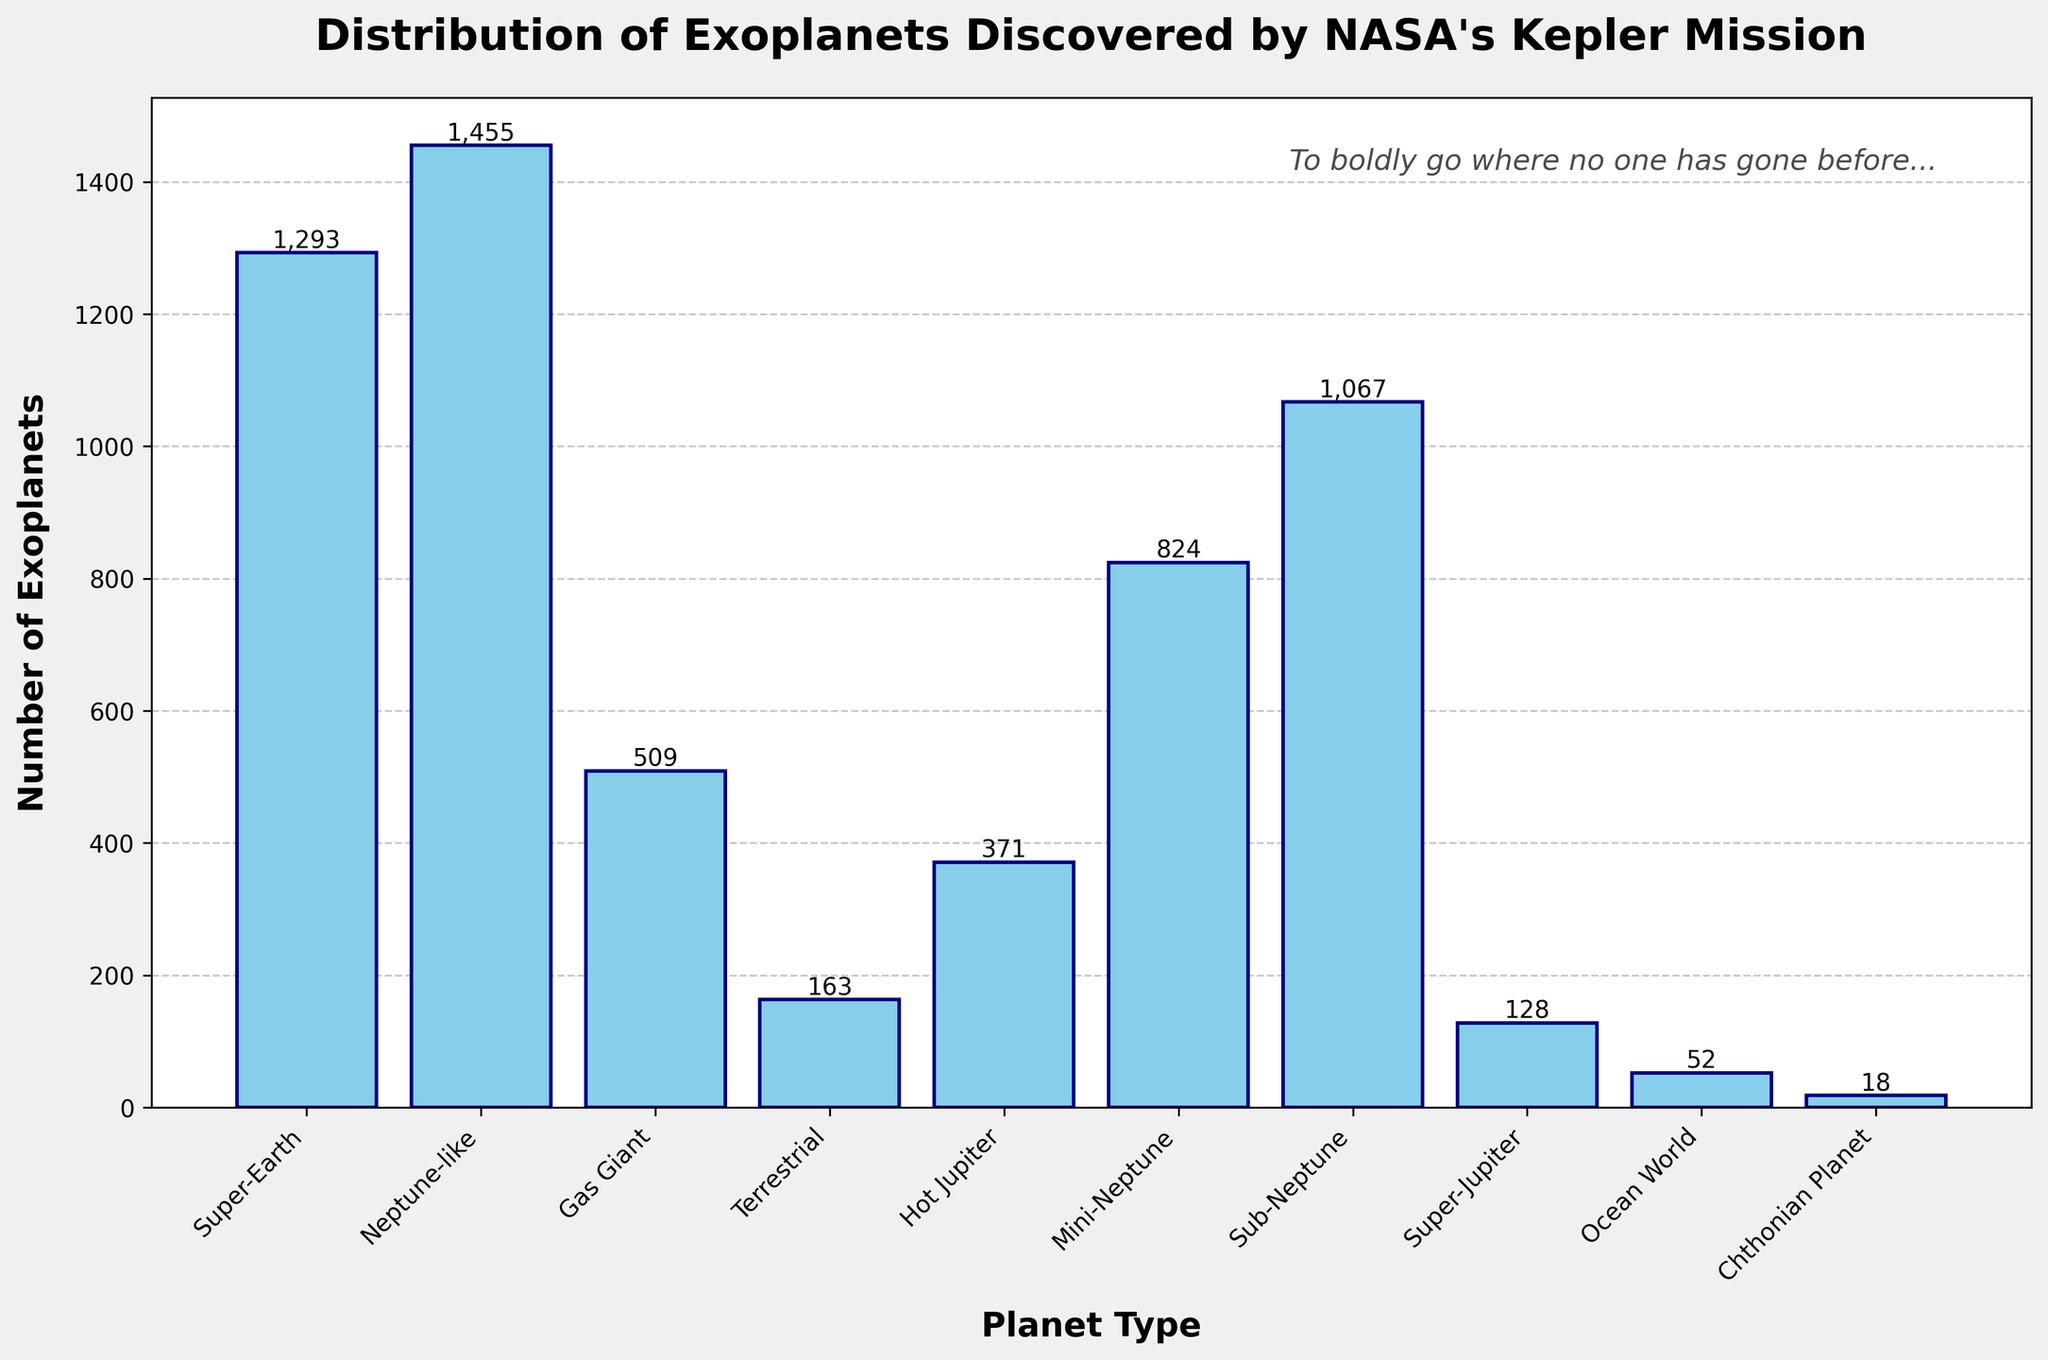What planet type has the highest number of exoplanets discovered? The tallest bar corresponds to the planet type with the highest number of exoplanets. In the figure, the Neptune-like planet type has the highest bar.
Answer: Neptune-like What is the total number of exoplanets discovered by NASA's Kepler mission in the chart? Sum the values for all the planet types. The total is 1293 (Super-Earth) + 1455 (Neptune-like) + 509 (Gas Giant) + 163 (Terrestrial) + 371 (Hot Jupiter) + 824 (Mini-Neptune) + 1067 (Sub-Neptune) + 128 (Super-Jupiter) + 52 (Ocean World) + 18 (Chthonian Planet).
Answer: 5,880 Which planet type has more exoplanets discovered, Super-Earth or Mini-Neptune? Compare the heights of the bars for Super-Earth and Mini-Neptune. The bar for Super-Earth is taller than that for Mini-Neptune.
Answer: Super-Earth What is the difference in the number of exoplanets discovered between Sub-Neptune and Gas Giant? Subtract the number of exoplanets of Gas Giant from Sub-Neptune. 1067 (Sub-Neptune) - 509 (Gas Giant).
Answer: 558 How many more exoplanets are there in the Neptune-like category compared to Hot Jupiter? Subtract the number of exoplanets in Hot Jupiter from Neptune-like. 1455 (Neptune-like) - 371 (Hot Jupiter).
Answer: 1,084 What is the average number of exoplanets discovered per planet type? Divide the total number of exoplanets by the number of planet types: 5,880 total exoplanets / 10 planet types.
Answer: 588 Which has fewer discovered exoplanets, Ocean World or Chthonian Planet? Compare the heights of the bars for Ocean World and Chthonian Planet. The bar for Chthonian Planet is shorter than that for Ocean World.
Answer: Chthonian Planet How does the number of exoplanets discovered in the Terrestrial category compare to the Gas Giant category? Compare the heights of the bars for Terrestrial and Gas Giant. The bar for Gas Giant is taller than that for Terrestrial.
Answer: Gas Giant has more Which two planet types combined have the most exoplanets discovered? Calculate and compare sums for possible pairs of planet types. The combination with the highest total is 1455 (Neptune-like) + 1067 (Sub-Neptune) = 2,522.
Answer: Neptune-like and Sub-Neptune How much taller is the gas giant's bar compared to the ocean world's bar? Gas Giant has 509 exoplanets, while Ocean World has 52 exoplanets. Subtract the number of exoplanets in Ocean World from Gas Giant: 509 - 52.
Answer: 457 